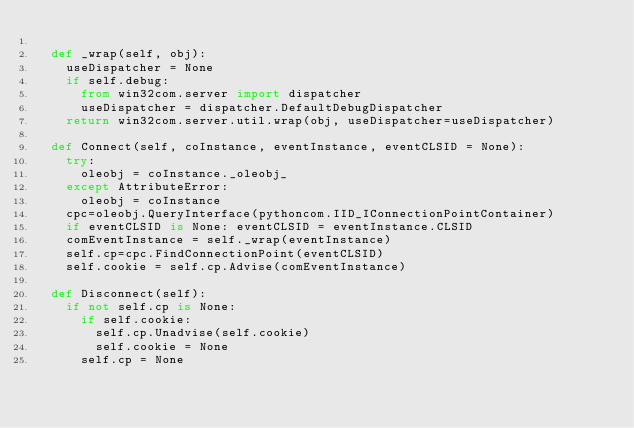<code> <loc_0><loc_0><loc_500><loc_500><_Python_>
	def _wrap(self, obj):
		useDispatcher = None
		if self.debug:
			from win32com.server import dispatcher
			useDispatcher = dispatcher.DefaultDebugDispatcher
		return win32com.server.util.wrap(obj, useDispatcher=useDispatcher)

	def Connect(self, coInstance, eventInstance, eventCLSID = None):
		try:
			oleobj = coInstance._oleobj_
		except AttributeError:
			oleobj = coInstance
		cpc=oleobj.QueryInterface(pythoncom.IID_IConnectionPointContainer)
		if eventCLSID is None: eventCLSID = eventInstance.CLSID
		comEventInstance = self._wrap(eventInstance)
		self.cp=cpc.FindConnectionPoint(eventCLSID)
		self.cookie = self.cp.Advise(comEventInstance)

	def Disconnect(self):
		if not self.cp is None:
			if self.cookie:
				self.cp.Unadvise(self.cookie)
				self.cookie = None
			self.cp = None
</code> 